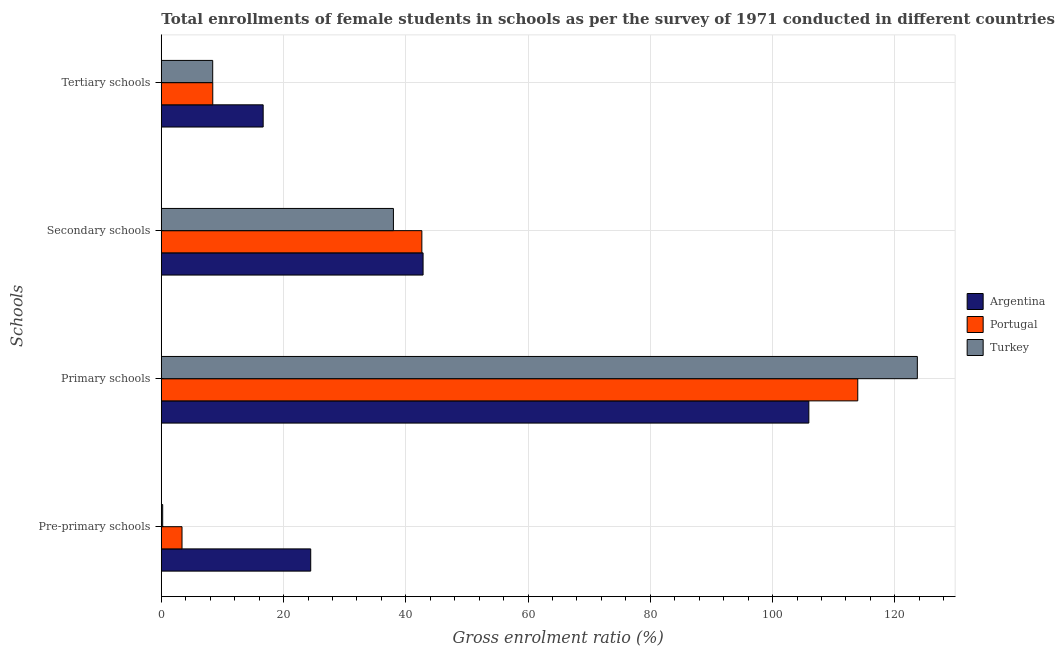How many different coloured bars are there?
Your answer should be very brief. 3. How many groups of bars are there?
Offer a very short reply. 4. Are the number of bars per tick equal to the number of legend labels?
Keep it short and to the point. Yes. Are the number of bars on each tick of the Y-axis equal?
Offer a terse response. Yes. What is the label of the 1st group of bars from the top?
Your response must be concise. Tertiary schools. What is the gross enrolment ratio(female) in secondary schools in Portugal?
Your answer should be compact. 42.62. Across all countries, what is the maximum gross enrolment ratio(female) in pre-primary schools?
Provide a succinct answer. 24.44. Across all countries, what is the minimum gross enrolment ratio(female) in pre-primary schools?
Your response must be concise. 0.22. In which country was the gross enrolment ratio(female) in secondary schools minimum?
Your answer should be very brief. Turkey. What is the total gross enrolment ratio(female) in primary schools in the graph?
Give a very brief answer. 343.55. What is the difference between the gross enrolment ratio(female) in tertiary schools in Argentina and that in Portugal?
Make the answer very short. 8.25. What is the difference between the gross enrolment ratio(female) in primary schools in Turkey and the gross enrolment ratio(female) in pre-primary schools in Portugal?
Ensure brevity in your answer.  120.3. What is the average gross enrolment ratio(female) in secondary schools per country?
Offer a terse response. 41.14. What is the difference between the gross enrolment ratio(female) in tertiary schools and gross enrolment ratio(female) in primary schools in Argentina?
Your response must be concise. -89.27. What is the ratio of the gross enrolment ratio(female) in pre-primary schools in Portugal to that in Turkey?
Give a very brief answer. 15.08. Is the difference between the gross enrolment ratio(female) in pre-primary schools in Argentina and Turkey greater than the difference between the gross enrolment ratio(female) in primary schools in Argentina and Turkey?
Provide a succinct answer. Yes. What is the difference between the highest and the second highest gross enrolment ratio(female) in tertiary schools?
Offer a terse response. 8.25. What is the difference between the highest and the lowest gross enrolment ratio(female) in pre-primary schools?
Give a very brief answer. 24.22. In how many countries, is the gross enrolment ratio(female) in pre-primary schools greater than the average gross enrolment ratio(female) in pre-primary schools taken over all countries?
Provide a succinct answer. 1. Is the sum of the gross enrolment ratio(female) in tertiary schools in Argentina and Portugal greater than the maximum gross enrolment ratio(female) in primary schools across all countries?
Keep it short and to the point. No. Is it the case that in every country, the sum of the gross enrolment ratio(female) in primary schools and gross enrolment ratio(female) in tertiary schools is greater than the sum of gross enrolment ratio(female) in secondary schools and gross enrolment ratio(female) in pre-primary schools?
Make the answer very short. No. How many bars are there?
Ensure brevity in your answer.  12. Are all the bars in the graph horizontal?
Keep it short and to the point. Yes. Are the values on the major ticks of X-axis written in scientific E-notation?
Offer a very short reply. No. How are the legend labels stacked?
Give a very brief answer. Vertical. What is the title of the graph?
Your answer should be compact. Total enrollments of female students in schools as per the survey of 1971 conducted in different countries. What is the label or title of the X-axis?
Offer a terse response. Gross enrolment ratio (%). What is the label or title of the Y-axis?
Offer a terse response. Schools. What is the Gross enrolment ratio (%) of Argentina in Pre-primary schools?
Give a very brief answer. 24.44. What is the Gross enrolment ratio (%) in Portugal in Pre-primary schools?
Give a very brief answer. 3.39. What is the Gross enrolment ratio (%) in Turkey in Pre-primary schools?
Make the answer very short. 0.22. What is the Gross enrolment ratio (%) in Argentina in Primary schools?
Ensure brevity in your answer.  105.93. What is the Gross enrolment ratio (%) of Portugal in Primary schools?
Offer a terse response. 113.93. What is the Gross enrolment ratio (%) in Turkey in Primary schools?
Provide a succinct answer. 123.68. What is the Gross enrolment ratio (%) in Argentina in Secondary schools?
Give a very brief answer. 42.82. What is the Gross enrolment ratio (%) of Portugal in Secondary schools?
Make the answer very short. 42.62. What is the Gross enrolment ratio (%) of Turkey in Secondary schools?
Your response must be concise. 37.97. What is the Gross enrolment ratio (%) of Argentina in Tertiary schools?
Give a very brief answer. 16.66. What is the Gross enrolment ratio (%) in Portugal in Tertiary schools?
Give a very brief answer. 8.42. What is the Gross enrolment ratio (%) in Turkey in Tertiary schools?
Ensure brevity in your answer.  8.41. Across all Schools, what is the maximum Gross enrolment ratio (%) of Argentina?
Make the answer very short. 105.93. Across all Schools, what is the maximum Gross enrolment ratio (%) of Portugal?
Give a very brief answer. 113.93. Across all Schools, what is the maximum Gross enrolment ratio (%) of Turkey?
Give a very brief answer. 123.68. Across all Schools, what is the minimum Gross enrolment ratio (%) of Argentina?
Your answer should be compact. 16.66. Across all Schools, what is the minimum Gross enrolment ratio (%) in Portugal?
Provide a short and direct response. 3.39. Across all Schools, what is the minimum Gross enrolment ratio (%) of Turkey?
Your answer should be compact. 0.22. What is the total Gross enrolment ratio (%) in Argentina in the graph?
Give a very brief answer. 189.86. What is the total Gross enrolment ratio (%) in Portugal in the graph?
Provide a short and direct response. 168.36. What is the total Gross enrolment ratio (%) in Turkey in the graph?
Ensure brevity in your answer.  170.28. What is the difference between the Gross enrolment ratio (%) of Argentina in Pre-primary schools and that in Primary schools?
Your response must be concise. -81.49. What is the difference between the Gross enrolment ratio (%) in Portugal in Pre-primary schools and that in Primary schools?
Make the answer very short. -110.55. What is the difference between the Gross enrolment ratio (%) in Turkey in Pre-primary schools and that in Primary schools?
Ensure brevity in your answer.  -123.46. What is the difference between the Gross enrolment ratio (%) of Argentina in Pre-primary schools and that in Secondary schools?
Your response must be concise. -18.38. What is the difference between the Gross enrolment ratio (%) in Portugal in Pre-primary schools and that in Secondary schools?
Provide a succinct answer. -39.24. What is the difference between the Gross enrolment ratio (%) in Turkey in Pre-primary schools and that in Secondary schools?
Ensure brevity in your answer.  -37.75. What is the difference between the Gross enrolment ratio (%) of Argentina in Pre-primary schools and that in Tertiary schools?
Offer a very short reply. 7.78. What is the difference between the Gross enrolment ratio (%) in Portugal in Pre-primary schools and that in Tertiary schools?
Keep it short and to the point. -5.03. What is the difference between the Gross enrolment ratio (%) of Turkey in Pre-primary schools and that in Tertiary schools?
Offer a very short reply. -8.18. What is the difference between the Gross enrolment ratio (%) in Argentina in Primary schools and that in Secondary schools?
Keep it short and to the point. 63.11. What is the difference between the Gross enrolment ratio (%) of Portugal in Primary schools and that in Secondary schools?
Keep it short and to the point. 71.31. What is the difference between the Gross enrolment ratio (%) of Turkey in Primary schools and that in Secondary schools?
Keep it short and to the point. 85.71. What is the difference between the Gross enrolment ratio (%) of Argentina in Primary schools and that in Tertiary schools?
Provide a short and direct response. 89.27. What is the difference between the Gross enrolment ratio (%) in Portugal in Primary schools and that in Tertiary schools?
Provide a succinct answer. 105.52. What is the difference between the Gross enrolment ratio (%) in Turkey in Primary schools and that in Tertiary schools?
Make the answer very short. 115.28. What is the difference between the Gross enrolment ratio (%) of Argentina in Secondary schools and that in Tertiary schools?
Make the answer very short. 26.16. What is the difference between the Gross enrolment ratio (%) of Portugal in Secondary schools and that in Tertiary schools?
Your answer should be very brief. 34.21. What is the difference between the Gross enrolment ratio (%) in Turkey in Secondary schools and that in Tertiary schools?
Your response must be concise. 29.57. What is the difference between the Gross enrolment ratio (%) in Argentina in Pre-primary schools and the Gross enrolment ratio (%) in Portugal in Primary schools?
Your response must be concise. -89.49. What is the difference between the Gross enrolment ratio (%) in Argentina in Pre-primary schools and the Gross enrolment ratio (%) in Turkey in Primary schools?
Provide a succinct answer. -99.24. What is the difference between the Gross enrolment ratio (%) in Portugal in Pre-primary schools and the Gross enrolment ratio (%) in Turkey in Primary schools?
Provide a succinct answer. -120.3. What is the difference between the Gross enrolment ratio (%) in Argentina in Pre-primary schools and the Gross enrolment ratio (%) in Portugal in Secondary schools?
Ensure brevity in your answer.  -18.18. What is the difference between the Gross enrolment ratio (%) in Argentina in Pre-primary schools and the Gross enrolment ratio (%) in Turkey in Secondary schools?
Your response must be concise. -13.53. What is the difference between the Gross enrolment ratio (%) in Portugal in Pre-primary schools and the Gross enrolment ratio (%) in Turkey in Secondary schools?
Your answer should be compact. -34.59. What is the difference between the Gross enrolment ratio (%) of Argentina in Pre-primary schools and the Gross enrolment ratio (%) of Portugal in Tertiary schools?
Your answer should be compact. 16.03. What is the difference between the Gross enrolment ratio (%) of Argentina in Pre-primary schools and the Gross enrolment ratio (%) of Turkey in Tertiary schools?
Your answer should be compact. 16.04. What is the difference between the Gross enrolment ratio (%) of Portugal in Pre-primary schools and the Gross enrolment ratio (%) of Turkey in Tertiary schools?
Provide a succinct answer. -5.02. What is the difference between the Gross enrolment ratio (%) in Argentina in Primary schools and the Gross enrolment ratio (%) in Portugal in Secondary schools?
Give a very brief answer. 63.31. What is the difference between the Gross enrolment ratio (%) of Argentina in Primary schools and the Gross enrolment ratio (%) of Turkey in Secondary schools?
Your answer should be very brief. 67.96. What is the difference between the Gross enrolment ratio (%) of Portugal in Primary schools and the Gross enrolment ratio (%) of Turkey in Secondary schools?
Make the answer very short. 75.96. What is the difference between the Gross enrolment ratio (%) in Argentina in Primary schools and the Gross enrolment ratio (%) in Portugal in Tertiary schools?
Offer a very short reply. 97.52. What is the difference between the Gross enrolment ratio (%) in Argentina in Primary schools and the Gross enrolment ratio (%) in Turkey in Tertiary schools?
Ensure brevity in your answer.  97.53. What is the difference between the Gross enrolment ratio (%) of Portugal in Primary schools and the Gross enrolment ratio (%) of Turkey in Tertiary schools?
Ensure brevity in your answer.  105.53. What is the difference between the Gross enrolment ratio (%) of Argentina in Secondary schools and the Gross enrolment ratio (%) of Portugal in Tertiary schools?
Offer a terse response. 34.41. What is the difference between the Gross enrolment ratio (%) in Argentina in Secondary schools and the Gross enrolment ratio (%) in Turkey in Tertiary schools?
Provide a succinct answer. 34.42. What is the difference between the Gross enrolment ratio (%) of Portugal in Secondary schools and the Gross enrolment ratio (%) of Turkey in Tertiary schools?
Your response must be concise. 34.22. What is the average Gross enrolment ratio (%) in Argentina per Schools?
Offer a terse response. 47.46. What is the average Gross enrolment ratio (%) in Portugal per Schools?
Offer a very short reply. 42.09. What is the average Gross enrolment ratio (%) of Turkey per Schools?
Your response must be concise. 42.57. What is the difference between the Gross enrolment ratio (%) in Argentina and Gross enrolment ratio (%) in Portugal in Pre-primary schools?
Provide a succinct answer. 21.06. What is the difference between the Gross enrolment ratio (%) of Argentina and Gross enrolment ratio (%) of Turkey in Pre-primary schools?
Ensure brevity in your answer.  24.22. What is the difference between the Gross enrolment ratio (%) of Portugal and Gross enrolment ratio (%) of Turkey in Pre-primary schools?
Give a very brief answer. 3.16. What is the difference between the Gross enrolment ratio (%) of Argentina and Gross enrolment ratio (%) of Portugal in Primary schools?
Provide a short and direct response. -8. What is the difference between the Gross enrolment ratio (%) of Argentina and Gross enrolment ratio (%) of Turkey in Primary schools?
Ensure brevity in your answer.  -17.75. What is the difference between the Gross enrolment ratio (%) of Portugal and Gross enrolment ratio (%) of Turkey in Primary schools?
Ensure brevity in your answer.  -9.75. What is the difference between the Gross enrolment ratio (%) in Argentina and Gross enrolment ratio (%) in Portugal in Secondary schools?
Give a very brief answer. 0.2. What is the difference between the Gross enrolment ratio (%) of Argentina and Gross enrolment ratio (%) of Turkey in Secondary schools?
Offer a very short reply. 4.85. What is the difference between the Gross enrolment ratio (%) of Portugal and Gross enrolment ratio (%) of Turkey in Secondary schools?
Ensure brevity in your answer.  4.65. What is the difference between the Gross enrolment ratio (%) of Argentina and Gross enrolment ratio (%) of Portugal in Tertiary schools?
Offer a terse response. 8.25. What is the difference between the Gross enrolment ratio (%) in Argentina and Gross enrolment ratio (%) in Turkey in Tertiary schools?
Your response must be concise. 8.26. What is the difference between the Gross enrolment ratio (%) of Portugal and Gross enrolment ratio (%) of Turkey in Tertiary schools?
Offer a very short reply. 0.01. What is the ratio of the Gross enrolment ratio (%) of Argentina in Pre-primary schools to that in Primary schools?
Your answer should be compact. 0.23. What is the ratio of the Gross enrolment ratio (%) of Portugal in Pre-primary schools to that in Primary schools?
Make the answer very short. 0.03. What is the ratio of the Gross enrolment ratio (%) of Turkey in Pre-primary schools to that in Primary schools?
Provide a short and direct response. 0. What is the ratio of the Gross enrolment ratio (%) in Argentina in Pre-primary schools to that in Secondary schools?
Provide a short and direct response. 0.57. What is the ratio of the Gross enrolment ratio (%) of Portugal in Pre-primary schools to that in Secondary schools?
Provide a succinct answer. 0.08. What is the ratio of the Gross enrolment ratio (%) of Turkey in Pre-primary schools to that in Secondary schools?
Provide a short and direct response. 0.01. What is the ratio of the Gross enrolment ratio (%) of Argentina in Pre-primary schools to that in Tertiary schools?
Your answer should be compact. 1.47. What is the ratio of the Gross enrolment ratio (%) of Portugal in Pre-primary schools to that in Tertiary schools?
Provide a succinct answer. 0.4. What is the ratio of the Gross enrolment ratio (%) in Turkey in Pre-primary schools to that in Tertiary schools?
Provide a succinct answer. 0.03. What is the ratio of the Gross enrolment ratio (%) of Argentina in Primary schools to that in Secondary schools?
Keep it short and to the point. 2.47. What is the ratio of the Gross enrolment ratio (%) in Portugal in Primary schools to that in Secondary schools?
Give a very brief answer. 2.67. What is the ratio of the Gross enrolment ratio (%) of Turkey in Primary schools to that in Secondary schools?
Give a very brief answer. 3.26. What is the ratio of the Gross enrolment ratio (%) in Argentina in Primary schools to that in Tertiary schools?
Ensure brevity in your answer.  6.36. What is the ratio of the Gross enrolment ratio (%) of Portugal in Primary schools to that in Tertiary schools?
Keep it short and to the point. 13.54. What is the ratio of the Gross enrolment ratio (%) in Turkey in Primary schools to that in Tertiary schools?
Make the answer very short. 14.71. What is the ratio of the Gross enrolment ratio (%) of Argentina in Secondary schools to that in Tertiary schools?
Provide a succinct answer. 2.57. What is the ratio of the Gross enrolment ratio (%) in Portugal in Secondary schools to that in Tertiary schools?
Your answer should be compact. 5.06. What is the ratio of the Gross enrolment ratio (%) of Turkey in Secondary schools to that in Tertiary schools?
Offer a terse response. 4.52. What is the difference between the highest and the second highest Gross enrolment ratio (%) in Argentina?
Provide a succinct answer. 63.11. What is the difference between the highest and the second highest Gross enrolment ratio (%) of Portugal?
Provide a short and direct response. 71.31. What is the difference between the highest and the second highest Gross enrolment ratio (%) of Turkey?
Your answer should be very brief. 85.71. What is the difference between the highest and the lowest Gross enrolment ratio (%) of Argentina?
Provide a succinct answer. 89.27. What is the difference between the highest and the lowest Gross enrolment ratio (%) of Portugal?
Offer a terse response. 110.55. What is the difference between the highest and the lowest Gross enrolment ratio (%) of Turkey?
Your answer should be compact. 123.46. 